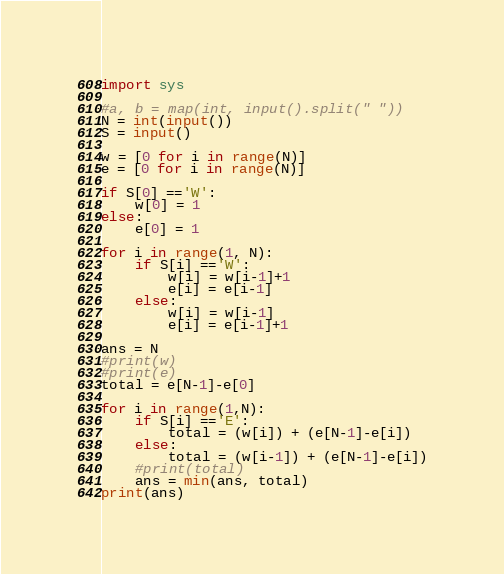Convert code to text. <code><loc_0><loc_0><loc_500><loc_500><_Python_>import sys

#a, b = map(int, input().split(" "))
N = int(input())
S = input()

w = [0 for i in range(N)]
e = [0 for i in range(N)]

if S[0] =='W':
	w[0] = 1
else:
	e[0] = 1

for i in range(1, N):
	if S[i] =='W':
		w[i] = w[i-1]+1
		e[i] = e[i-1]
	else:
		w[i] = w[i-1]
		e[i] = e[i-1]+1	

ans = N
#print(w)
#print(e)
total = e[N-1]-e[0]

for i in range(1,N):
	if S[i] =='E':
		total = (w[i]) + (e[N-1]-e[i])
	else:
		total = (w[i-1]) + (e[N-1]-e[i])
	#print(total)
	ans = min(ans, total)
print(ans)</code> 